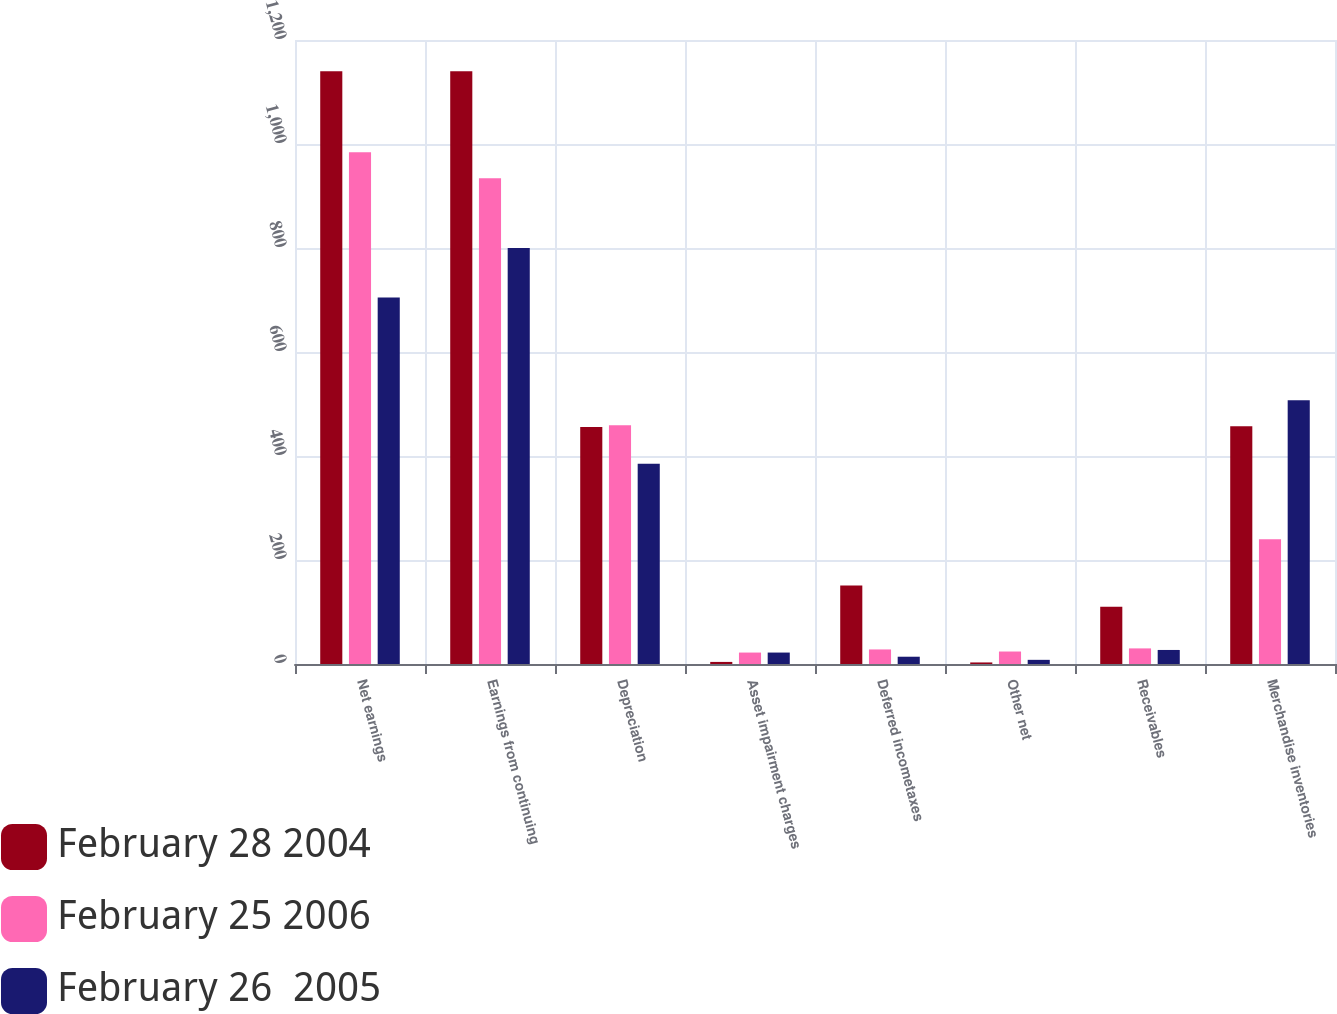Convert chart to OTSL. <chart><loc_0><loc_0><loc_500><loc_500><stacked_bar_chart><ecel><fcel>Net earnings<fcel>Earnings from continuing<fcel>Depreciation<fcel>Asset impairment charges<fcel>Deferred incometaxes<fcel>Other net<fcel>Receivables<fcel>Merchandise inventories<nl><fcel>February 28 2004<fcel>1140<fcel>1140<fcel>456<fcel>4<fcel>151<fcel>3<fcel>110<fcel>457<nl><fcel>February 25 2006<fcel>984<fcel>934<fcel>459<fcel>22<fcel>28<fcel>24<fcel>30<fcel>240<nl><fcel>February 26  2005<fcel>705<fcel>800<fcel>385<fcel>22<fcel>14<fcel>8<fcel>27<fcel>507<nl></chart> 